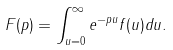Convert formula to latex. <formula><loc_0><loc_0><loc_500><loc_500>F ( p ) = \int ^ { \infty } _ { u = 0 } e ^ { - p u } f ( u ) d u .</formula> 